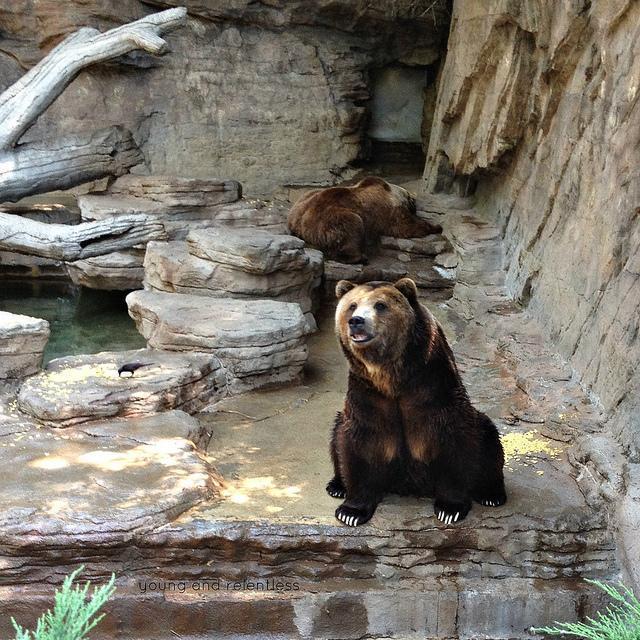How many bears are in the photo?
Give a very brief answer. 2. 